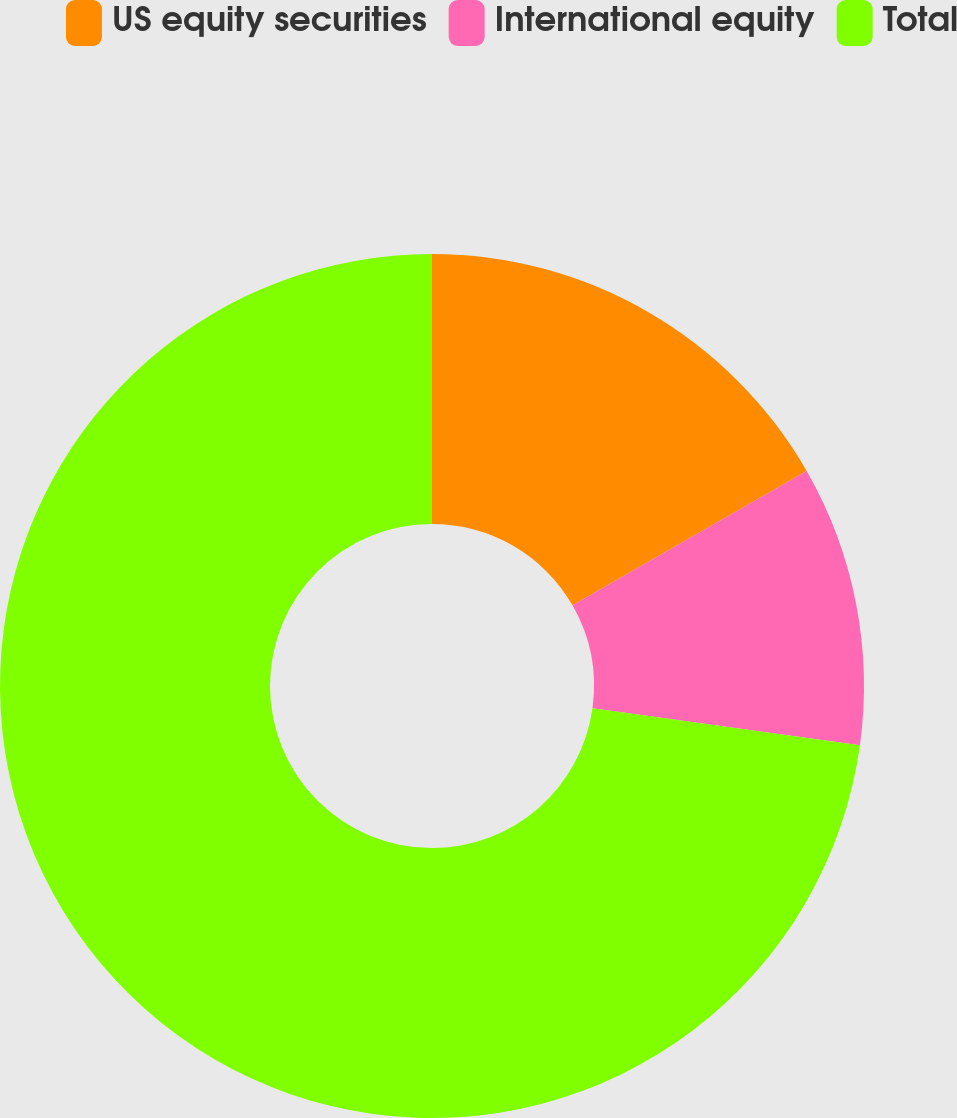<chart> <loc_0><loc_0><loc_500><loc_500><pie_chart><fcel>US equity securities<fcel>International equity<fcel>Total<nl><fcel>16.71%<fcel>10.48%<fcel>72.82%<nl></chart> 